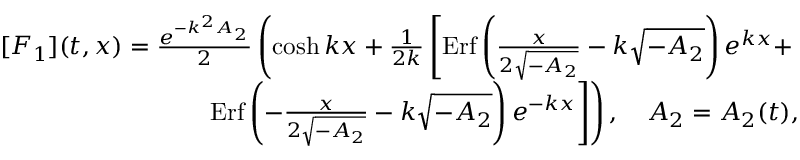<formula> <loc_0><loc_0><loc_500><loc_500>\begin{array} { r l r } & { [ F _ { 1 } ] ( t , x ) = \frac { e ^ { - k ^ { 2 } A _ { 2 } } } { 2 } \left ( \cosh k x + \frac { 1 } { 2 k } \left [ E r f \left ( \frac { x } { 2 \sqrt { - A _ { 2 } } } - k \sqrt { - A _ { 2 } } \right ) e ^ { k x } + } \\ & { E r f \left ( - \frac { x } { 2 \sqrt { - A _ { 2 } } } - k \sqrt { - A _ { 2 } } \right ) e ^ { - k x } \right ] \right ) , \quad A _ { 2 } = A _ { 2 } ( t ) , } \end{array}</formula> 